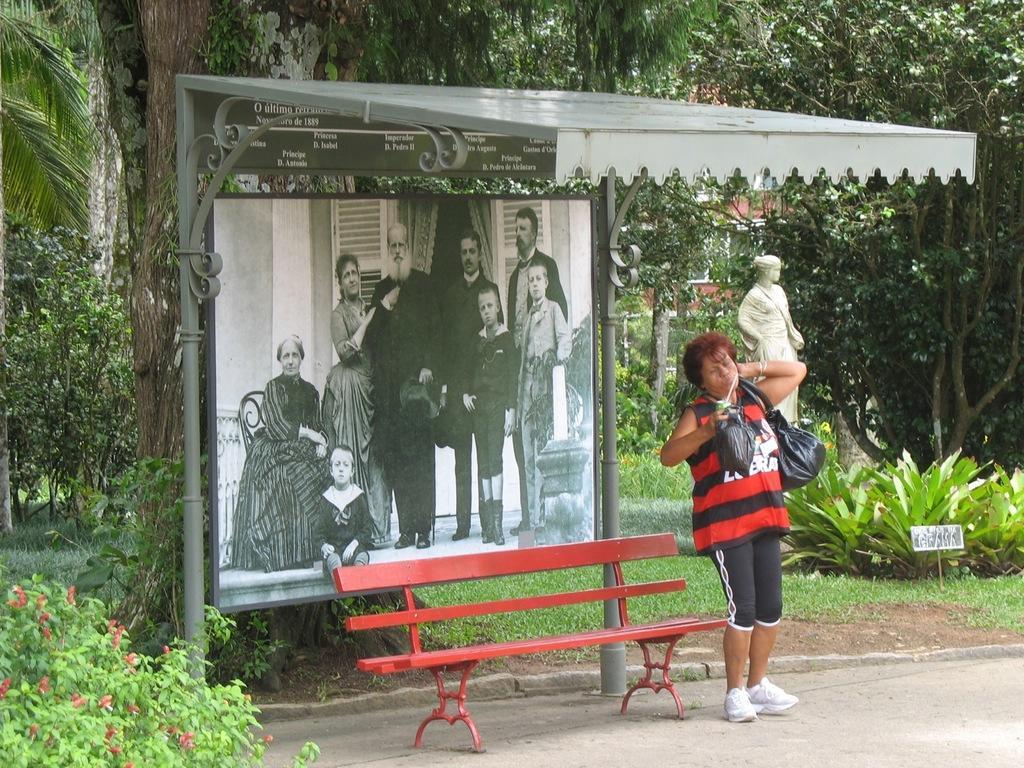Please provide a concise description of this image. Under this open shed we can see a picture, bench and person. This person wore a bag and holding an object. Background there are trees, grass, plants, sculpture and building. In this picture we can see people, one person is sitting on a chair. 